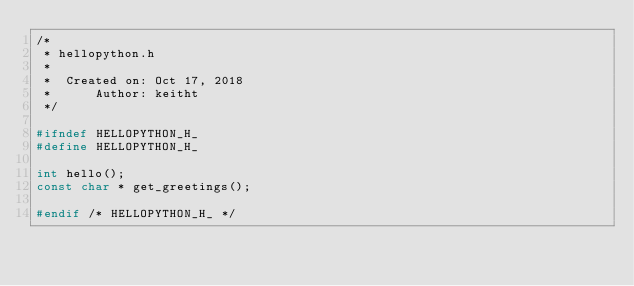<code> <loc_0><loc_0><loc_500><loc_500><_C_>/*
 * hellopython.h
 *
 *  Created on: Oct 17, 2018
 *      Author: keitht
 */

#ifndef HELLOPYTHON_H_
#define HELLOPYTHON_H_

int hello();
const char * get_greetings();

#endif /* HELLOPYTHON_H_ */
</code> 